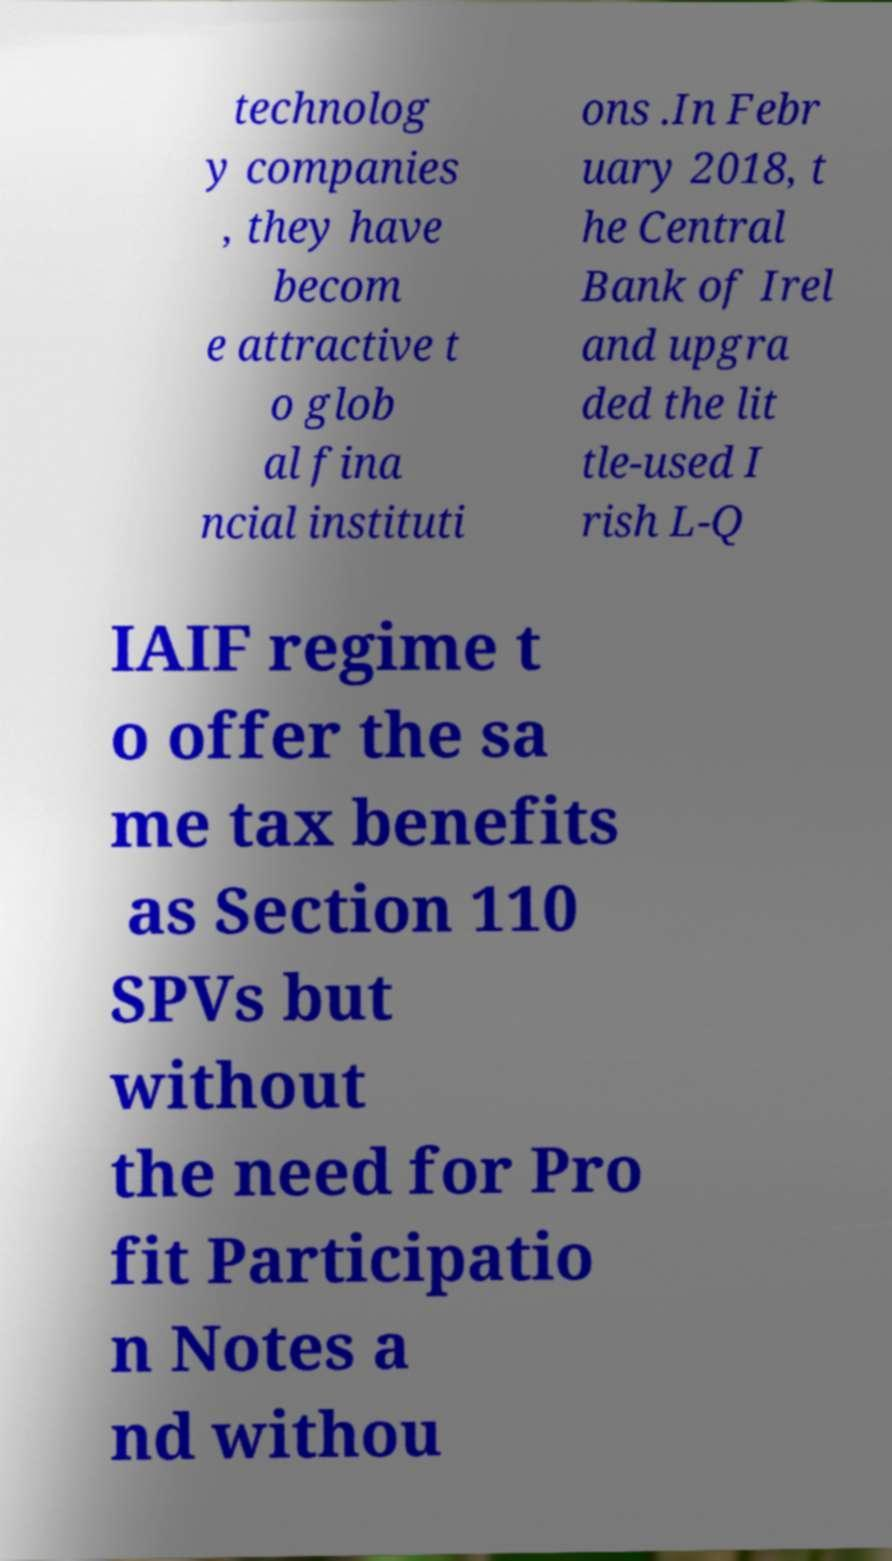What messages or text are displayed in this image? I need them in a readable, typed format. technolog y companies , they have becom e attractive t o glob al fina ncial instituti ons .In Febr uary 2018, t he Central Bank of Irel and upgra ded the lit tle-used I rish L-Q IAIF regime t o offer the sa me tax benefits as Section 110 SPVs but without the need for Pro fit Participatio n Notes a nd withou 